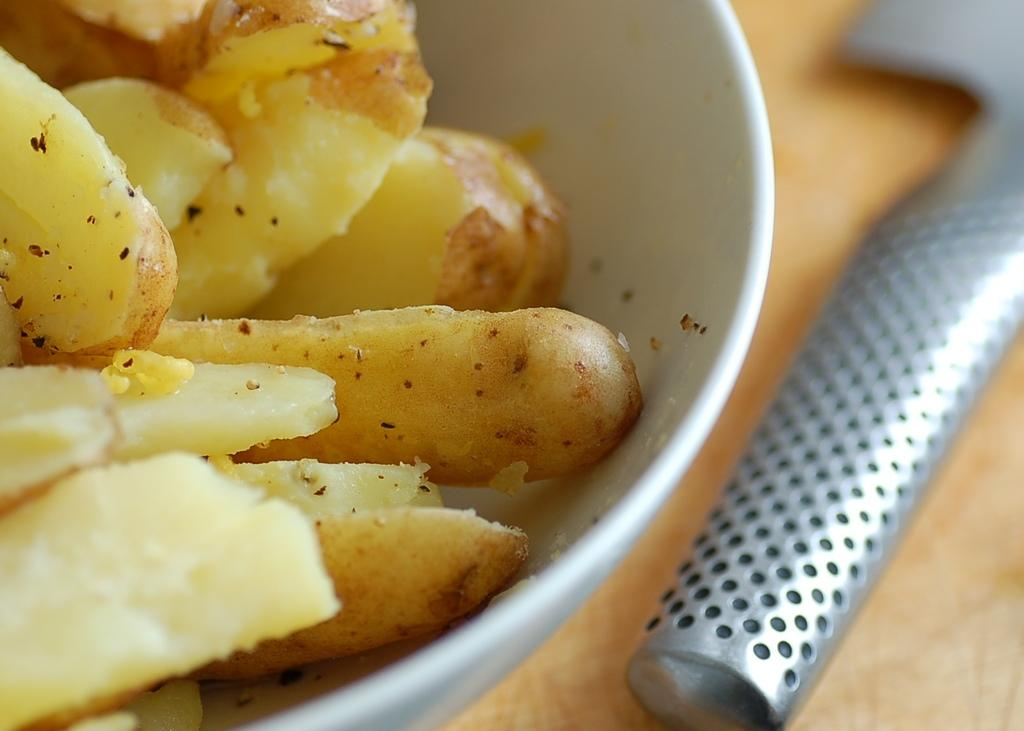What color is the bowl in the image? The bowl in the image is white. What is inside the bowl? The bowl contains potato slices. Where is the bowl located? The bowl is placed on a table. What is the material of the object beside the bowl? The object beside the bowl is made of metal. What is the name of the son of the person who prepared the potato slices in the image? There is no information about the person who prepared the potato slices or their son in the image. 